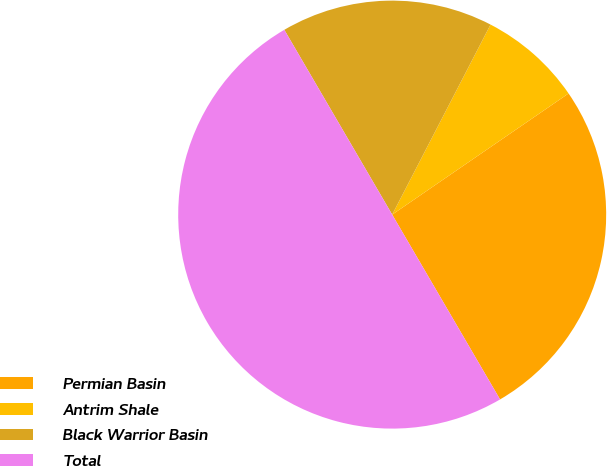Convert chart to OTSL. <chart><loc_0><loc_0><loc_500><loc_500><pie_chart><fcel>Permian Basin<fcel>Antrim Shale<fcel>Black Warrior Basin<fcel>Total<nl><fcel>26.17%<fcel>7.82%<fcel>16.01%<fcel>50.0%<nl></chart> 